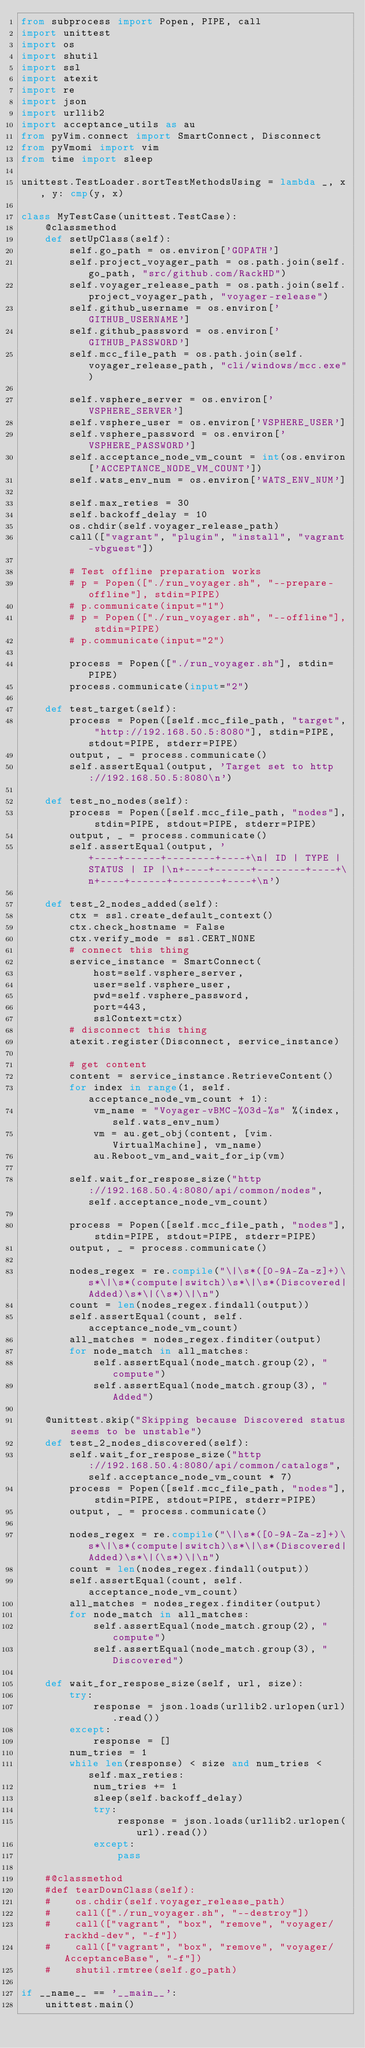<code> <loc_0><loc_0><loc_500><loc_500><_Python_>from subprocess import Popen, PIPE, call
import unittest
import os
import shutil
import ssl
import atexit
import re
import json
import urllib2
import acceptance_utils as au
from pyVim.connect import SmartConnect, Disconnect
from pyVmomi import vim
from time import sleep

unittest.TestLoader.sortTestMethodsUsing = lambda _, x, y: cmp(y, x)

class MyTestCase(unittest.TestCase):
    @classmethod
    def setUpClass(self):
        self.go_path = os.environ['GOPATH']
        self.project_voyager_path = os.path.join(self.go_path, "src/github.com/RackHD")
        self.voyager_release_path = os.path.join(self.project_voyager_path, "voyager-release")
        self.github_username = os.environ['GITHUB_USERNAME']
        self.github_password = os.environ['GITHUB_PASSWORD']
        self.mcc_file_path = os.path.join(self.voyager_release_path, "cli/windows/mcc.exe")

        self.vsphere_server = os.environ['VSPHERE_SERVER']
        self.vsphere_user = os.environ['VSPHERE_USER']
        self.vsphere_password = os.environ['VSPHERE_PASSWORD']
        self.acceptance_node_vm_count = int(os.environ['ACCEPTANCE_NODE_VM_COUNT'])
        self.wats_env_num = os.environ['WATS_ENV_NUM']

        self.max_reties = 30
        self.backoff_delay = 10
        os.chdir(self.voyager_release_path)
        call(["vagrant", "plugin", "install", "vagrant-vbguest"])

        # Test offline preparation works
        # p = Popen(["./run_voyager.sh", "--prepare-offline"], stdin=PIPE)
        # p.communicate(input="1")
        # p = Popen(["./run_voyager.sh", "--offline"], stdin=PIPE)
        # p.communicate(input="2")

        process = Popen(["./run_voyager.sh"], stdin=PIPE)
        process.communicate(input="2")

    def test_target(self):
        process = Popen([self.mcc_file_path, "target", "http://192.168.50.5:8080"], stdin=PIPE, stdout=PIPE, stderr=PIPE)
        output, _ = process.communicate()
        self.assertEqual(output, 'Target set to http://192.168.50.5:8080\n')

    def test_no_nodes(self):
        process = Popen([self.mcc_file_path, "nodes"], stdin=PIPE, stdout=PIPE, stderr=PIPE)
        output, _ = process.communicate()
        self.assertEqual(output, '+----+------+--------+----+\n| ID | TYPE | STATUS | IP |\n+----+------+--------+----+\n+----+------+--------+----+\n')

    def test_2_nodes_added(self):
        ctx = ssl.create_default_context()
        ctx.check_hostname = False
        ctx.verify_mode = ssl.CERT_NONE
        # connect this thing
        service_instance = SmartConnect(
            host=self.vsphere_server,
            user=self.vsphere_user,
            pwd=self.vsphere_password,
            port=443,
            sslContext=ctx)
        # disconnect this thing
        atexit.register(Disconnect, service_instance)

        # get content
        content = service_instance.RetrieveContent()
        for index in range(1, self.acceptance_node_vm_count + 1):
            vm_name = "Voyager-vBMC-%03d-%s" %(index, self.wats_env_num)
            vm = au.get_obj(content, [vim.VirtualMachine], vm_name)
            au.Reboot_vm_and_wait_for_ip(vm)

        self.wait_for_respose_size("http://192.168.50.4:8080/api/common/nodes", self.acceptance_node_vm_count)

        process = Popen([self.mcc_file_path, "nodes"], stdin=PIPE, stdout=PIPE, stderr=PIPE)
        output, _ = process.communicate()

        nodes_regex = re.compile("\|\s*([0-9A-Za-z]+)\s*\|\s*(compute|switch)\s*\|\s*(Discovered|Added)\s*\|(\s*)\|\n")
        count = len(nodes_regex.findall(output))
        self.assertEqual(count, self.acceptance_node_vm_count)
        all_matches = nodes_regex.finditer(output)
        for node_match in all_matches:
            self.assertEqual(node_match.group(2), "compute")
            self.assertEqual(node_match.group(3), "Added")

    @unittest.skip("Skipping because Discovered status seems to be unstable")
    def test_2_nodes_discovered(self):
        self.wait_for_respose_size("http://192.168.50.4:8080/api/common/catalogs", self.acceptance_node_vm_count * 7)
        process = Popen([self.mcc_file_path, "nodes"], stdin=PIPE, stdout=PIPE, stderr=PIPE)
        output, _ = process.communicate()

        nodes_regex = re.compile("\|\s*([0-9A-Za-z]+)\s*\|\s*(compute|switch)\s*\|\s*(Discovered|Added)\s*\|(\s*)\|\n")
        count = len(nodes_regex.findall(output))
        self.assertEqual(count, self.acceptance_node_vm_count)
        all_matches = nodes_regex.finditer(output)
        for node_match in all_matches:
            self.assertEqual(node_match.group(2), "compute")
            self.assertEqual(node_match.group(3), "Discovered")

    def wait_for_respose_size(self, url, size):
        try:
            response = json.loads(urllib2.urlopen(url).read())
        except:
            response = []
        num_tries = 1
        while len(response) < size and num_tries < self.max_reties:
            num_tries += 1
            sleep(self.backoff_delay)
            try:
                response = json.loads(urllib2.urlopen(url).read())
            except:
                pass

    #@classmethod
    #def tearDownClass(self):
    #    os.chdir(self.voyager_release_path)
    #    call(["./run_voyager.sh", "--destroy"])
    #    call(["vagrant", "box", "remove", "voyager/rackhd-dev", "-f"])
    #    call(["vagrant", "box", "remove", "voyager/AcceptanceBase", "-f"])
    #    shutil.rmtree(self.go_path)

if __name__ == '__main__':
    unittest.main()
</code> 